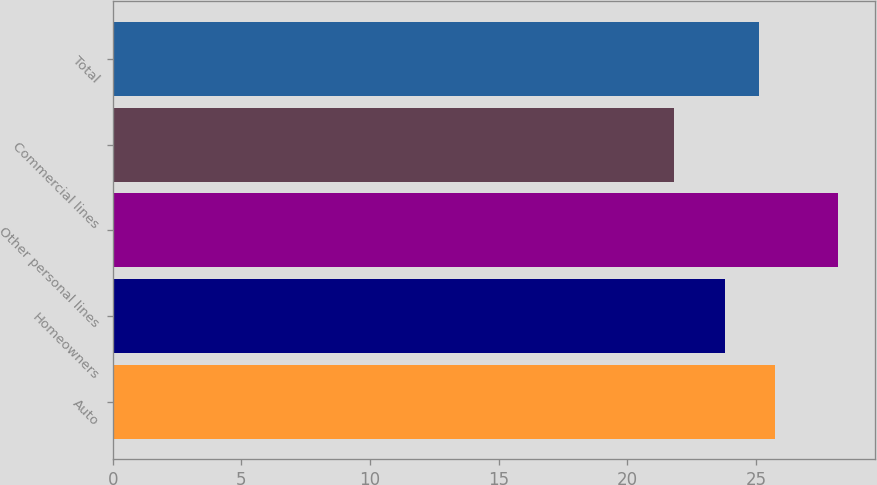Convert chart to OTSL. <chart><loc_0><loc_0><loc_500><loc_500><bar_chart><fcel>Auto<fcel>Homeowners<fcel>Other personal lines<fcel>Commercial lines<fcel>Total<nl><fcel>25.74<fcel>23.8<fcel>28.2<fcel>21.8<fcel>25.1<nl></chart> 